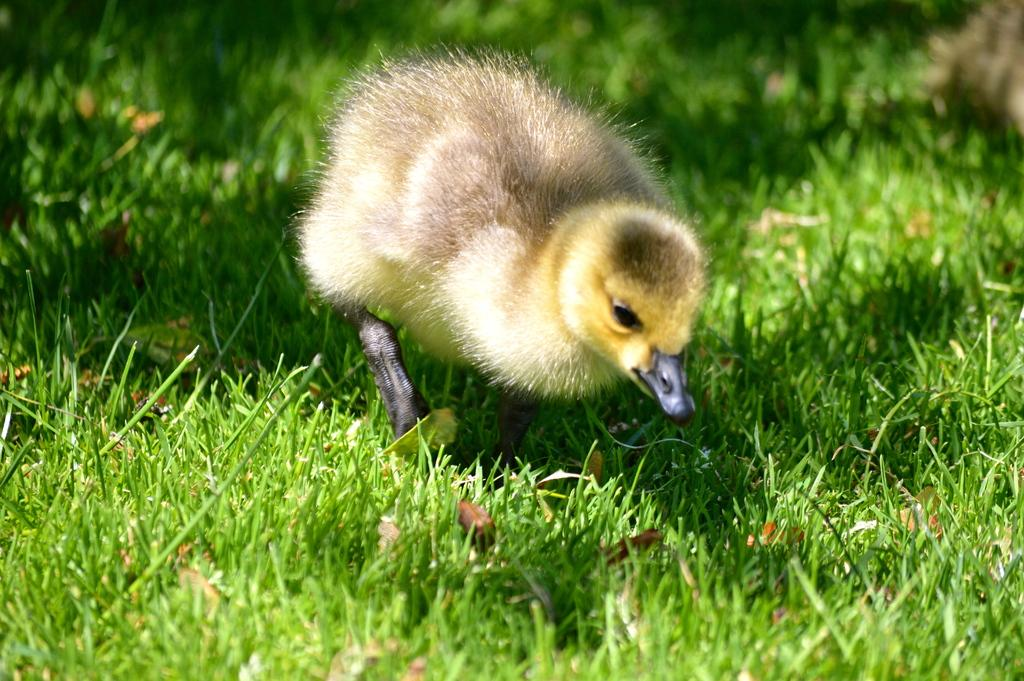What animal is the main subject of the image? There is a duck in the image. Where is the duck located in the image? The duck is in the center of the image. What type of environment is the duck in? The duck is on the grassland. What type of letter is the duck holding in the image? There is no letter present in the image, as the duck is not holding anything. 